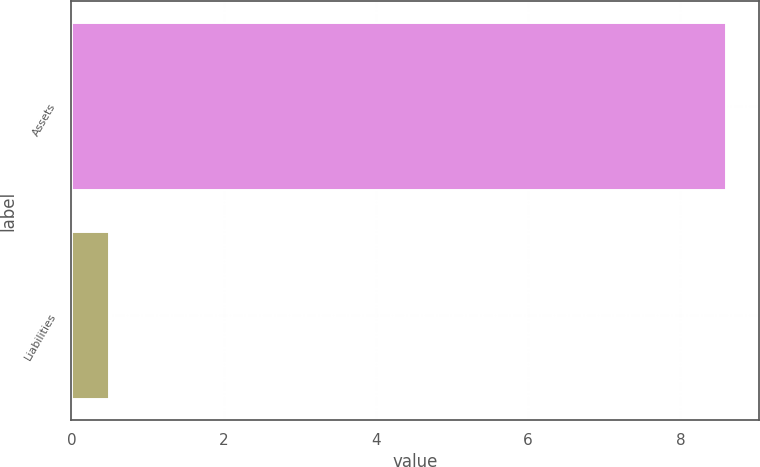Convert chart. <chart><loc_0><loc_0><loc_500><loc_500><bar_chart><fcel>Assets<fcel>Liabilities<nl><fcel>8.6<fcel>0.5<nl></chart> 